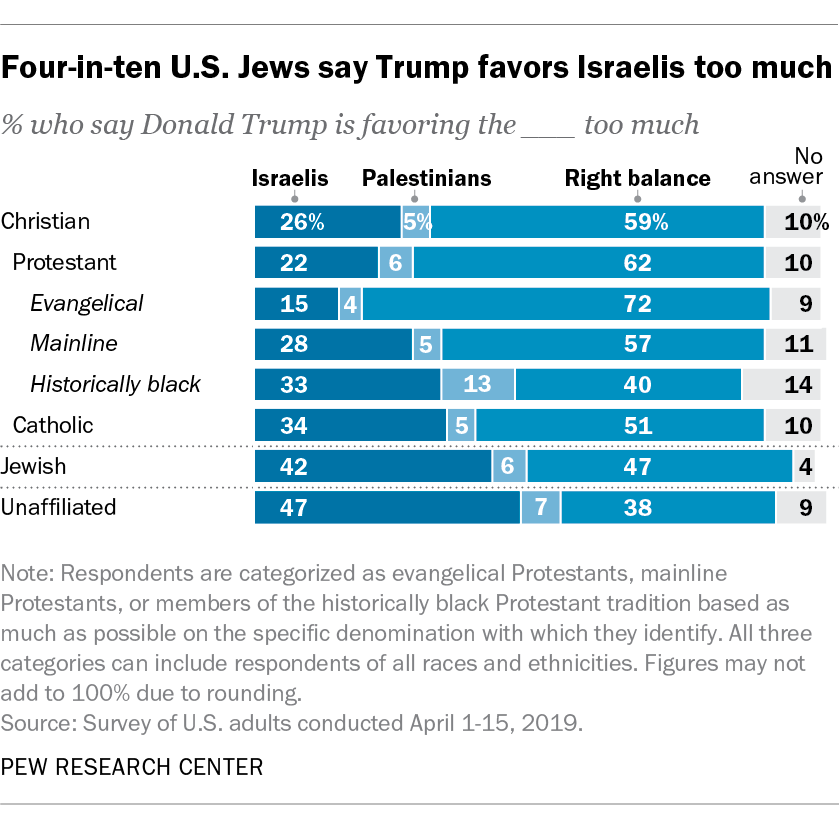Identify some key points in this picture. What is the difference in value between the highest values in Judaism and Catholicism? The highest value in the dark blue bar is 47. 